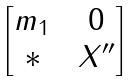Convert formula to latex. <formula><loc_0><loc_0><loc_500><loc_500>\begin{bmatrix} m _ { 1 } \, & \, 0 \\ * \, & \, X ^ { \prime \prime } \end{bmatrix}</formula> 